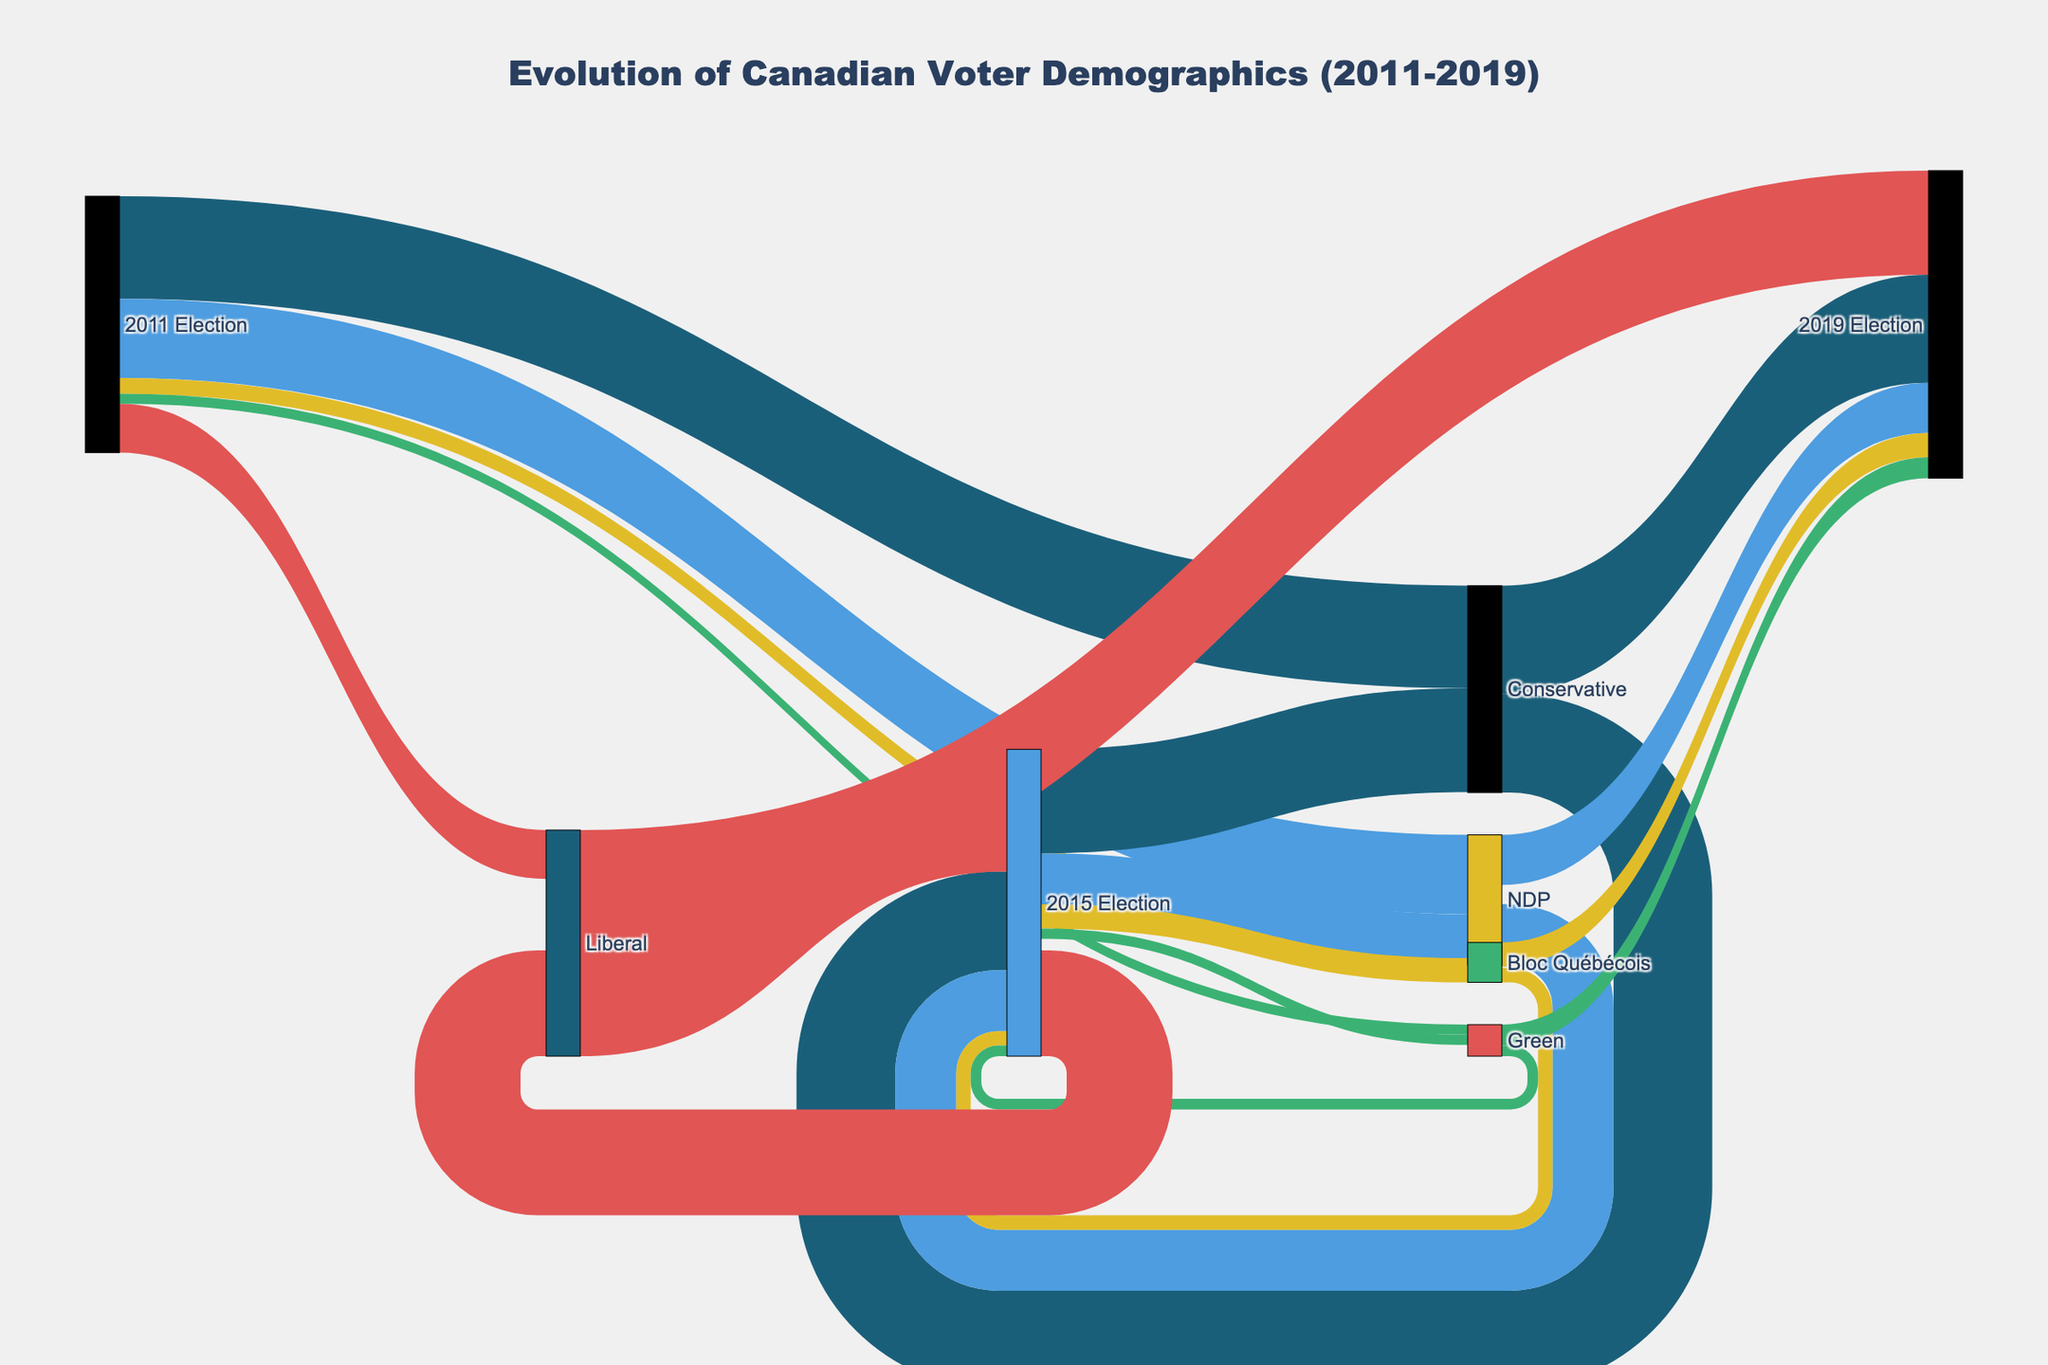What is the title of the Sankey diagram? Look at the top center of the diagram where the title is displayed.
Answer: Evolution of Canadian Voter Demographics (2011-2019) How many total votes were cast in the 2011 Election? Sum the values of all categories under "2011 Election" source. 5832401 + 4508474 + 2783175 + 889788 + 572095 = 14503933
Answer: 14,503,933 Which party had the highest number of votes in the 2019 Election? Look at the target nodes labeled with "2019 Election" and compare the values. The Conservative party has 6,155,662 votes which is higher than others.
Answer: Conservative What was the difference in votes between the Liberal party in the 2011 Election and the 2015 Election? Subtract the votes in 2011 (2,783,175) from the votes in 2015 (6,943,276). 6943276 - 2783175 = 4160101
Answer: 4,160,101 Which party increased its vote count in every election from 2011 to 2019? Check the vote counts for each party across 2011, 2015, and 2019 Elections. Only the Green Party shows an increase: 572095 (2011) → 602944 (2015) → 1189607 (2019).
Answer: Green How many parties are featured in the diagram? Count the distinct nodes representing political parties across all elections. These are Conservative, NDP, Liberal, Bloc Québécois, and Green.
Answer: 5 What is the total number of votes received by the NDP across all elections? Sum the votes received by the NDP in each election. 4508474 (2011) + 3470350 (2015) + 2849214 (2019) = 10828038
Answer: 10,828,038 Compare the vote count for the Bloc Québécois between 2011 and 2019. Which year had more votes? Compare the votes: 889788 (2011) with 1387030 (2019). The 2019 count is greater.
Answer: 2019 How did the vote count change for the Conservative party from 2015 Election to 2019 Election? Subtract the votes in 2015 (5911588) from the votes in 2019 (6155662). 6155662 - 5911588 = 244074
Answer: Increased by 244,074 What trend can you observe about the Liberal party's vote count from 2011 to 2019? Observe the vote count changes: 2783175 (2011) → 6943276 (2015) → 5915950 (2019). It increased significantly from 2011 to 2015, then slightly decreased from 2015 to 2019.
Answer: Increased then slightly decreased 